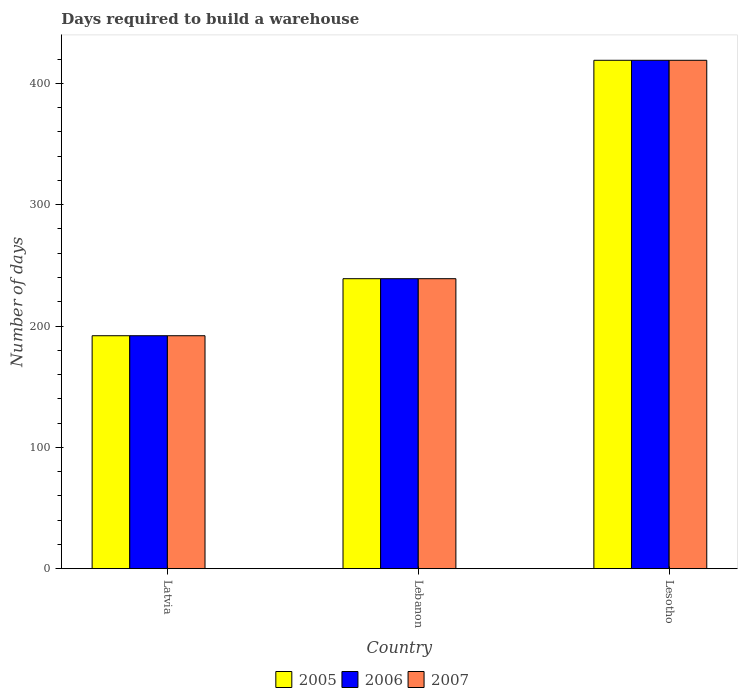How many different coloured bars are there?
Make the answer very short. 3. Are the number of bars on each tick of the X-axis equal?
Provide a succinct answer. Yes. How many bars are there on the 3rd tick from the right?
Your response must be concise. 3. What is the label of the 3rd group of bars from the left?
Your response must be concise. Lesotho. In how many cases, is the number of bars for a given country not equal to the number of legend labels?
Offer a terse response. 0. What is the days required to build a warehouse in in 2005 in Lesotho?
Ensure brevity in your answer.  419. Across all countries, what is the maximum days required to build a warehouse in in 2006?
Provide a succinct answer. 419. Across all countries, what is the minimum days required to build a warehouse in in 2007?
Ensure brevity in your answer.  192. In which country was the days required to build a warehouse in in 2007 maximum?
Keep it short and to the point. Lesotho. In which country was the days required to build a warehouse in in 2006 minimum?
Your answer should be compact. Latvia. What is the total days required to build a warehouse in in 2007 in the graph?
Ensure brevity in your answer.  850. What is the difference between the days required to build a warehouse in in 2006 in Latvia and that in Lebanon?
Ensure brevity in your answer.  -47. What is the difference between the days required to build a warehouse in in 2007 in Lebanon and the days required to build a warehouse in in 2006 in Lesotho?
Offer a very short reply. -180. What is the average days required to build a warehouse in in 2005 per country?
Provide a short and direct response. 283.33. What is the ratio of the days required to build a warehouse in in 2005 in Latvia to that in Lesotho?
Make the answer very short. 0.46. Is the days required to build a warehouse in in 2005 in Lebanon less than that in Lesotho?
Offer a very short reply. Yes. Is the difference between the days required to build a warehouse in in 2005 in Latvia and Lesotho greater than the difference between the days required to build a warehouse in in 2007 in Latvia and Lesotho?
Provide a succinct answer. No. What is the difference between the highest and the second highest days required to build a warehouse in in 2005?
Offer a terse response. -227. What is the difference between the highest and the lowest days required to build a warehouse in in 2005?
Give a very brief answer. 227. In how many countries, is the days required to build a warehouse in in 2007 greater than the average days required to build a warehouse in in 2007 taken over all countries?
Provide a succinct answer. 1. Is the sum of the days required to build a warehouse in in 2007 in Latvia and Lesotho greater than the maximum days required to build a warehouse in in 2005 across all countries?
Provide a succinct answer. Yes. What does the 3rd bar from the right in Lebanon represents?
Your answer should be very brief. 2005. Is it the case that in every country, the sum of the days required to build a warehouse in in 2006 and days required to build a warehouse in in 2005 is greater than the days required to build a warehouse in in 2007?
Ensure brevity in your answer.  Yes. How many bars are there?
Your answer should be very brief. 9. How many countries are there in the graph?
Keep it short and to the point. 3. What is the difference between two consecutive major ticks on the Y-axis?
Give a very brief answer. 100. Are the values on the major ticks of Y-axis written in scientific E-notation?
Your answer should be very brief. No. Does the graph contain grids?
Your answer should be compact. No. Where does the legend appear in the graph?
Offer a very short reply. Bottom center. How are the legend labels stacked?
Provide a succinct answer. Horizontal. What is the title of the graph?
Your answer should be very brief. Days required to build a warehouse. Does "1962" appear as one of the legend labels in the graph?
Your answer should be compact. No. What is the label or title of the X-axis?
Offer a terse response. Country. What is the label or title of the Y-axis?
Offer a very short reply. Number of days. What is the Number of days in 2005 in Latvia?
Your answer should be very brief. 192. What is the Number of days in 2006 in Latvia?
Your answer should be very brief. 192. What is the Number of days of 2007 in Latvia?
Your answer should be very brief. 192. What is the Number of days of 2005 in Lebanon?
Your answer should be very brief. 239. What is the Number of days of 2006 in Lebanon?
Make the answer very short. 239. What is the Number of days in 2007 in Lebanon?
Your answer should be very brief. 239. What is the Number of days of 2005 in Lesotho?
Make the answer very short. 419. What is the Number of days in 2006 in Lesotho?
Make the answer very short. 419. What is the Number of days in 2007 in Lesotho?
Your answer should be compact. 419. Across all countries, what is the maximum Number of days of 2005?
Your answer should be compact. 419. Across all countries, what is the maximum Number of days in 2006?
Your answer should be compact. 419. Across all countries, what is the maximum Number of days in 2007?
Your answer should be compact. 419. Across all countries, what is the minimum Number of days in 2005?
Make the answer very short. 192. Across all countries, what is the minimum Number of days in 2006?
Offer a terse response. 192. Across all countries, what is the minimum Number of days in 2007?
Offer a terse response. 192. What is the total Number of days in 2005 in the graph?
Provide a succinct answer. 850. What is the total Number of days in 2006 in the graph?
Give a very brief answer. 850. What is the total Number of days in 2007 in the graph?
Provide a succinct answer. 850. What is the difference between the Number of days of 2005 in Latvia and that in Lebanon?
Provide a short and direct response. -47. What is the difference between the Number of days in 2006 in Latvia and that in Lebanon?
Give a very brief answer. -47. What is the difference between the Number of days of 2007 in Latvia and that in Lebanon?
Your response must be concise. -47. What is the difference between the Number of days of 2005 in Latvia and that in Lesotho?
Ensure brevity in your answer.  -227. What is the difference between the Number of days in 2006 in Latvia and that in Lesotho?
Offer a terse response. -227. What is the difference between the Number of days in 2007 in Latvia and that in Lesotho?
Offer a terse response. -227. What is the difference between the Number of days in 2005 in Lebanon and that in Lesotho?
Your response must be concise. -180. What is the difference between the Number of days of 2006 in Lebanon and that in Lesotho?
Ensure brevity in your answer.  -180. What is the difference between the Number of days in 2007 in Lebanon and that in Lesotho?
Offer a terse response. -180. What is the difference between the Number of days of 2005 in Latvia and the Number of days of 2006 in Lebanon?
Provide a succinct answer. -47. What is the difference between the Number of days of 2005 in Latvia and the Number of days of 2007 in Lebanon?
Keep it short and to the point. -47. What is the difference between the Number of days in 2006 in Latvia and the Number of days in 2007 in Lebanon?
Ensure brevity in your answer.  -47. What is the difference between the Number of days in 2005 in Latvia and the Number of days in 2006 in Lesotho?
Your answer should be compact. -227. What is the difference between the Number of days of 2005 in Latvia and the Number of days of 2007 in Lesotho?
Your answer should be compact. -227. What is the difference between the Number of days in 2006 in Latvia and the Number of days in 2007 in Lesotho?
Keep it short and to the point. -227. What is the difference between the Number of days of 2005 in Lebanon and the Number of days of 2006 in Lesotho?
Give a very brief answer. -180. What is the difference between the Number of days of 2005 in Lebanon and the Number of days of 2007 in Lesotho?
Keep it short and to the point. -180. What is the difference between the Number of days in 2006 in Lebanon and the Number of days in 2007 in Lesotho?
Keep it short and to the point. -180. What is the average Number of days of 2005 per country?
Provide a short and direct response. 283.33. What is the average Number of days in 2006 per country?
Make the answer very short. 283.33. What is the average Number of days of 2007 per country?
Your answer should be very brief. 283.33. What is the difference between the Number of days in 2005 and Number of days in 2006 in Latvia?
Your answer should be very brief. 0. What is the difference between the Number of days of 2006 and Number of days of 2007 in Latvia?
Offer a terse response. 0. What is the difference between the Number of days in 2005 and Number of days in 2006 in Lebanon?
Keep it short and to the point. 0. What is the difference between the Number of days in 2005 and Number of days in 2007 in Lebanon?
Provide a succinct answer. 0. What is the difference between the Number of days of 2005 and Number of days of 2006 in Lesotho?
Keep it short and to the point. 0. What is the difference between the Number of days in 2005 and Number of days in 2007 in Lesotho?
Your answer should be compact. 0. What is the difference between the Number of days of 2006 and Number of days of 2007 in Lesotho?
Your answer should be very brief. 0. What is the ratio of the Number of days of 2005 in Latvia to that in Lebanon?
Give a very brief answer. 0.8. What is the ratio of the Number of days of 2006 in Latvia to that in Lebanon?
Make the answer very short. 0.8. What is the ratio of the Number of days in 2007 in Latvia to that in Lebanon?
Offer a terse response. 0.8. What is the ratio of the Number of days of 2005 in Latvia to that in Lesotho?
Provide a short and direct response. 0.46. What is the ratio of the Number of days of 2006 in Latvia to that in Lesotho?
Provide a short and direct response. 0.46. What is the ratio of the Number of days of 2007 in Latvia to that in Lesotho?
Offer a very short reply. 0.46. What is the ratio of the Number of days in 2005 in Lebanon to that in Lesotho?
Keep it short and to the point. 0.57. What is the ratio of the Number of days of 2006 in Lebanon to that in Lesotho?
Provide a short and direct response. 0.57. What is the ratio of the Number of days of 2007 in Lebanon to that in Lesotho?
Your response must be concise. 0.57. What is the difference between the highest and the second highest Number of days of 2005?
Make the answer very short. 180. What is the difference between the highest and the second highest Number of days in 2006?
Provide a succinct answer. 180. What is the difference between the highest and the second highest Number of days of 2007?
Provide a succinct answer. 180. What is the difference between the highest and the lowest Number of days in 2005?
Keep it short and to the point. 227. What is the difference between the highest and the lowest Number of days of 2006?
Keep it short and to the point. 227. What is the difference between the highest and the lowest Number of days of 2007?
Give a very brief answer. 227. 